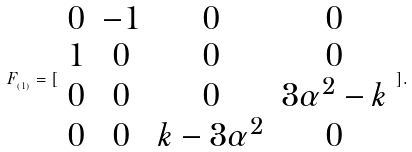Convert formula to latex. <formula><loc_0><loc_0><loc_500><loc_500>F _ { _ { ( 1 ) } } = [ \begin{array} { c c c c } 0 & - 1 & 0 & 0 \\ 1 & 0 & 0 & 0 \\ 0 & 0 & 0 & 3 \alpha ^ { 2 } - k \\ 0 & 0 & k - 3 \alpha ^ { 2 } & 0 \end{array} ] .</formula> 